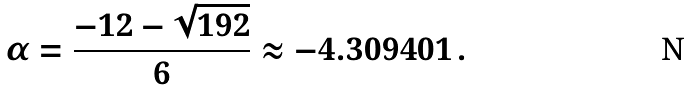Convert formula to latex. <formula><loc_0><loc_0><loc_500><loc_500>\alpha = \frac { - 1 2 - \sqrt { 1 9 2 } } { 6 } \approx - 4 . 3 0 9 4 0 1 \, .</formula> 